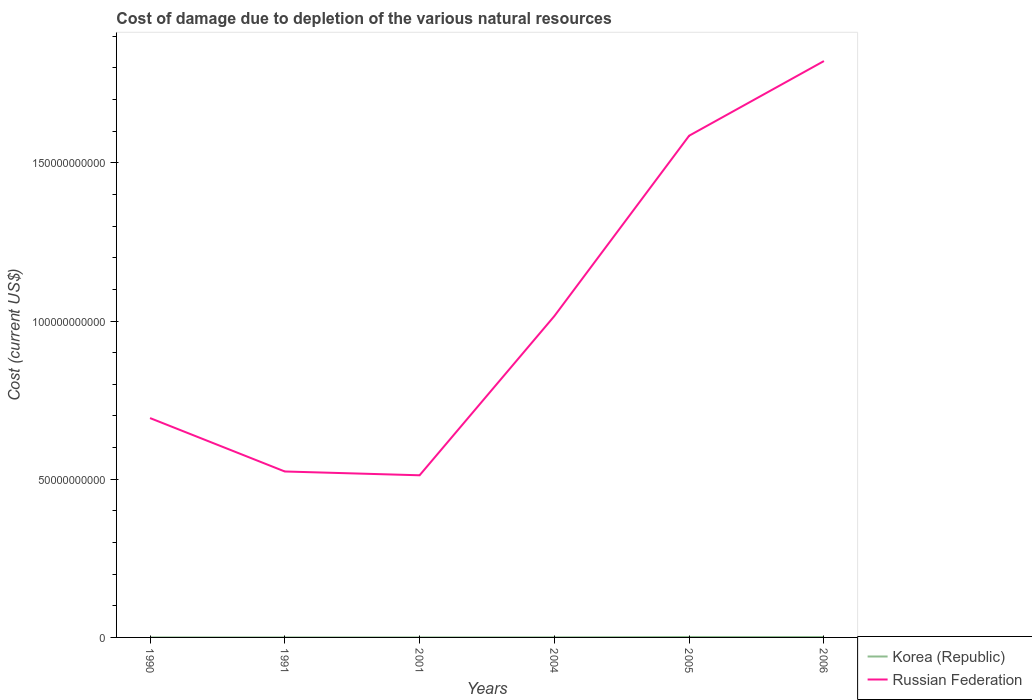How many different coloured lines are there?
Give a very brief answer. 2. Does the line corresponding to Korea (Republic) intersect with the line corresponding to Russian Federation?
Provide a short and direct response. No. Is the number of lines equal to the number of legend labels?
Offer a terse response. Yes. Across all years, what is the maximum cost of damage caused due to the depletion of various natural resources in Korea (Republic)?
Provide a short and direct response. 4.99e+06. In which year was the cost of damage caused due to the depletion of various natural resources in Korea (Republic) maximum?
Provide a short and direct response. 1991. What is the total cost of damage caused due to the depletion of various natural resources in Russian Federation in the graph?
Keep it short and to the point. -1.07e+11. What is the difference between the highest and the second highest cost of damage caused due to the depletion of various natural resources in Russian Federation?
Make the answer very short. 1.31e+11. What is the difference between the highest and the lowest cost of damage caused due to the depletion of various natural resources in Korea (Republic)?
Your answer should be very brief. 2. Is the cost of damage caused due to the depletion of various natural resources in Russian Federation strictly greater than the cost of damage caused due to the depletion of various natural resources in Korea (Republic) over the years?
Give a very brief answer. No. How many years are there in the graph?
Give a very brief answer. 6. What is the difference between two consecutive major ticks on the Y-axis?
Offer a terse response. 5.00e+1. Where does the legend appear in the graph?
Your answer should be very brief. Bottom right. How are the legend labels stacked?
Provide a short and direct response. Vertical. What is the title of the graph?
Offer a terse response. Cost of damage due to depletion of the various natural resources. Does "Guyana" appear as one of the legend labels in the graph?
Your response must be concise. No. What is the label or title of the X-axis?
Keep it short and to the point. Years. What is the label or title of the Y-axis?
Your answer should be compact. Cost (current US$). What is the Cost (current US$) in Korea (Republic) in 1990?
Your answer should be compact. 8.52e+06. What is the Cost (current US$) in Russian Federation in 1990?
Give a very brief answer. 6.93e+1. What is the Cost (current US$) in Korea (Republic) in 1991?
Provide a short and direct response. 4.99e+06. What is the Cost (current US$) of Russian Federation in 1991?
Provide a succinct answer. 5.24e+1. What is the Cost (current US$) in Korea (Republic) in 2001?
Ensure brevity in your answer.  6.16e+06. What is the Cost (current US$) of Russian Federation in 2001?
Offer a terse response. 5.12e+1. What is the Cost (current US$) of Korea (Republic) in 2004?
Your response must be concise. 3.01e+07. What is the Cost (current US$) of Russian Federation in 2004?
Make the answer very short. 1.02e+11. What is the Cost (current US$) in Korea (Republic) in 2005?
Provide a short and direct response. 1.42e+08. What is the Cost (current US$) in Russian Federation in 2005?
Provide a short and direct response. 1.59e+11. What is the Cost (current US$) of Korea (Republic) in 2006?
Offer a terse response. 1.27e+08. What is the Cost (current US$) of Russian Federation in 2006?
Offer a terse response. 1.82e+11. Across all years, what is the maximum Cost (current US$) in Korea (Republic)?
Provide a succinct answer. 1.42e+08. Across all years, what is the maximum Cost (current US$) in Russian Federation?
Your answer should be compact. 1.82e+11. Across all years, what is the minimum Cost (current US$) of Korea (Republic)?
Your response must be concise. 4.99e+06. Across all years, what is the minimum Cost (current US$) in Russian Federation?
Give a very brief answer. 5.12e+1. What is the total Cost (current US$) of Korea (Republic) in the graph?
Ensure brevity in your answer.  3.19e+08. What is the total Cost (current US$) in Russian Federation in the graph?
Offer a terse response. 6.15e+11. What is the difference between the Cost (current US$) in Korea (Republic) in 1990 and that in 1991?
Give a very brief answer. 3.53e+06. What is the difference between the Cost (current US$) in Russian Federation in 1990 and that in 1991?
Offer a terse response. 1.69e+1. What is the difference between the Cost (current US$) of Korea (Republic) in 1990 and that in 2001?
Provide a succinct answer. 2.36e+06. What is the difference between the Cost (current US$) in Russian Federation in 1990 and that in 2001?
Your answer should be very brief. 1.81e+1. What is the difference between the Cost (current US$) in Korea (Republic) in 1990 and that in 2004?
Keep it short and to the point. -2.16e+07. What is the difference between the Cost (current US$) of Russian Federation in 1990 and that in 2004?
Your response must be concise. -3.22e+1. What is the difference between the Cost (current US$) of Korea (Republic) in 1990 and that in 2005?
Your answer should be compact. -1.34e+08. What is the difference between the Cost (current US$) in Russian Federation in 1990 and that in 2005?
Offer a terse response. -8.92e+1. What is the difference between the Cost (current US$) in Korea (Republic) in 1990 and that in 2006?
Ensure brevity in your answer.  -1.19e+08. What is the difference between the Cost (current US$) in Russian Federation in 1990 and that in 2006?
Your response must be concise. -1.13e+11. What is the difference between the Cost (current US$) in Korea (Republic) in 1991 and that in 2001?
Give a very brief answer. -1.17e+06. What is the difference between the Cost (current US$) in Russian Federation in 1991 and that in 2001?
Your response must be concise. 1.20e+09. What is the difference between the Cost (current US$) in Korea (Republic) in 1991 and that in 2004?
Your answer should be compact. -2.51e+07. What is the difference between the Cost (current US$) in Russian Federation in 1991 and that in 2004?
Offer a very short reply. -4.91e+1. What is the difference between the Cost (current US$) in Korea (Republic) in 1991 and that in 2005?
Ensure brevity in your answer.  -1.37e+08. What is the difference between the Cost (current US$) in Russian Federation in 1991 and that in 2005?
Your answer should be compact. -1.06e+11. What is the difference between the Cost (current US$) of Korea (Republic) in 1991 and that in 2006?
Provide a short and direct response. -1.22e+08. What is the difference between the Cost (current US$) in Russian Federation in 1991 and that in 2006?
Provide a short and direct response. -1.30e+11. What is the difference between the Cost (current US$) of Korea (Republic) in 2001 and that in 2004?
Give a very brief answer. -2.40e+07. What is the difference between the Cost (current US$) of Russian Federation in 2001 and that in 2004?
Keep it short and to the point. -5.03e+1. What is the difference between the Cost (current US$) of Korea (Republic) in 2001 and that in 2005?
Offer a very short reply. -1.36e+08. What is the difference between the Cost (current US$) of Russian Federation in 2001 and that in 2005?
Your response must be concise. -1.07e+11. What is the difference between the Cost (current US$) of Korea (Republic) in 2001 and that in 2006?
Your answer should be compact. -1.21e+08. What is the difference between the Cost (current US$) of Russian Federation in 2001 and that in 2006?
Offer a terse response. -1.31e+11. What is the difference between the Cost (current US$) in Korea (Republic) in 2004 and that in 2005?
Your answer should be very brief. -1.12e+08. What is the difference between the Cost (current US$) in Russian Federation in 2004 and that in 2005?
Your answer should be very brief. -5.70e+1. What is the difference between the Cost (current US$) in Korea (Republic) in 2004 and that in 2006?
Provide a succinct answer. -9.72e+07. What is the difference between the Cost (current US$) in Russian Federation in 2004 and that in 2006?
Keep it short and to the point. -8.06e+1. What is the difference between the Cost (current US$) of Korea (Republic) in 2005 and that in 2006?
Ensure brevity in your answer.  1.48e+07. What is the difference between the Cost (current US$) in Russian Federation in 2005 and that in 2006?
Your answer should be compact. -2.36e+1. What is the difference between the Cost (current US$) in Korea (Republic) in 1990 and the Cost (current US$) in Russian Federation in 1991?
Your answer should be very brief. -5.24e+1. What is the difference between the Cost (current US$) of Korea (Republic) in 1990 and the Cost (current US$) of Russian Federation in 2001?
Your answer should be very brief. -5.12e+1. What is the difference between the Cost (current US$) in Korea (Republic) in 1990 and the Cost (current US$) in Russian Federation in 2004?
Your answer should be very brief. -1.02e+11. What is the difference between the Cost (current US$) in Korea (Republic) in 1990 and the Cost (current US$) in Russian Federation in 2005?
Ensure brevity in your answer.  -1.59e+11. What is the difference between the Cost (current US$) in Korea (Republic) in 1990 and the Cost (current US$) in Russian Federation in 2006?
Provide a short and direct response. -1.82e+11. What is the difference between the Cost (current US$) of Korea (Republic) in 1991 and the Cost (current US$) of Russian Federation in 2001?
Your response must be concise. -5.12e+1. What is the difference between the Cost (current US$) in Korea (Republic) in 1991 and the Cost (current US$) in Russian Federation in 2004?
Offer a very short reply. -1.02e+11. What is the difference between the Cost (current US$) of Korea (Republic) in 1991 and the Cost (current US$) of Russian Federation in 2005?
Your answer should be very brief. -1.59e+11. What is the difference between the Cost (current US$) of Korea (Republic) in 1991 and the Cost (current US$) of Russian Federation in 2006?
Offer a very short reply. -1.82e+11. What is the difference between the Cost (current US$) in Korea (Republic) in 2001 and the Cost (current US$) in Russian Federation in 2004?
Your answer should be very brief. -1.02e+11. What is the difference between the Cost (current US$) of Korea (Republic) in 2001 and the Cost (current US$) of Russian Federation in 2005?
Keep it short and to the point. -1.59e+11. What is the difference between the Cost (current US$) of Korea (Republic) in 2001 and the Cost (current US$) of Russian Federation in 2006?
Provide a short and direct response. -1.82e+11. What is the difference between the Cost (current US$) in Korea (Republic) in 2004 and the Cost (current US$) in Russian Federation in 2005?
Your answer should be very brief. -1.59e+11. What is the difference between the Cost (current US$) in Korea (Republic) in 2004 and the Cost (current US$) in Russian Federation in 2006?
Your response must be concise. -1.82e+11. What is the difference between the Cost (current US$) in Korea (Republic) in 2005 and the Cost (current US$) in Russian Federation in 2006?
Offer a very short reply. -1.82e+11. What is the average Cost (current US$) of Korea (Republic) per year?
Keep it short and to the point. 5.32e+07. What is the average Cost (current US$) in Russian Federation per year?
Your answer should be compact. 1.03e+11. In the year 1990, what is the difference between the Cost (current US$) of Korea (Republic) and Cost (current US$) of Russian Federation?
Offer a terse response. -6.93e+1. In the year 1991, what is the difference between the Cost (current US$) of Korea (Republic) and Cost (current US$) of Russian Federation?
Ensure brevity in your answer.  -5.24e+1. In the year 2001, what is the difference between the Cost (current US$) of Korea (Republic) and Cost (current US$) of Russian Federation?
Provide a succinct answer. -5.12e+1. In the year 2004, what is the difference between the Cost (current US$) of Korea (Republic) and Cost (current US$) of Russian Federation?
Give a very brief answer. -1.02e+11. In the year 2005, what is the difference between the Cost (current US$) in Korea (Republic) and Cost (current US$) in Russian Federation?
Keep it short and to the point. -1.58e+11. In the year 2006, what is the difference between the Cost (current US$) in Korea (Republic) and Cost (current US$) in Russian Federation?
Offer a very short reply. -1.82e+11. What is the ratio of the Cost (current US$) in Korea (Republic) in 1990 to that in 1991?
Offer a very short reply. 1.71. What is the ratio of the Cost (current US$) of Russian Federation in 1990 to that in 1991?
Keep it short and to the point. 1.32. What is the ratio of the Cost (current US$) of Korea (Republic) in 1990 to that in 2001?
Keep it short and to the point. 1.38. What is the ratio of the Cost (current US$) of Russian Federation in 1990 to that in 2001?
Your answer should be very brief. 1.35. What is the ratio of the Cost (current US$) of Korea (Republic) in 1990 to that in 2004?
Your response must be concise. 0.28. What is the ratio of the Cost (current US$) of Russian Federation in 1990 to that in 2004?
Keep it short and to the point. 0.68. What is the ratio of the Cost (current US$) in Korea (Republic) in 1990 to that in 2005?
Your answer should be very brief. 0.06. What is the ratio of the Cost (current US$) of Russian Federation in 1990 to that in 2005?
Offer a very short reply. 0.44. What is the ratio of the Cost (current US$) of Korea (Republic) in 1990 to that in 2006?
Offer a very short reply. 0.07. What is the ratio of the Cost (current US$) of Russian Federation in 1990 to that in 2006?
Your answer should be very brief. 0.38. What is the ratio of the Cost (current US$) in Korea (Republic) in 1991 to that in 2001?
Your answer should be very brief. 0.81. What is the ratio of the Cost (current US$) in Russian Federation in 1991 to that in 2001?
Make the answer very short. 1.02. What is the ratio of the Cost (current US$) of Korea (Republic) in 1991 to that in 2004?
Ensure brevity in your answer.  0.17. What is the ratio of the Cost (current US$) of Russian Federation in 1991 to that in 2004?
Keep it short and to the point. 0.52. What is the ratio of the Cost (current US$) of Korea (Republic) in 1991 to that in 2005?
Keep it short and to the point. 0.04. What is the ratio of the Cost (current US$) of Russian Federation in 1991 to that in 2005?
Ensure brevity in your answer.  0.33. What is the ratio of the Cost (current US$) of Korea (Republic) in 1991 to that in 2006?
Offer a terse response. 0.04. What is the ratio of the Cost (current US$) of Russian Federation in 1991 to that in 2006?
Offer a very short reply. 0.29. What is the ratio of the Cost (current US$) of Korea (Republic) in 2001 to that in 2004?
Your answer should be compact. 0.2. What is the ratio of the Cost (current US$) in Russian Federation in 2001 to that in 2004?
Offer a very short reply. 0.5. What is the ratio of the Cost (current US$) of Korea (Republic) in 2001 to that in 2005?
Your response must be concise. 0.04. What is the ratio of the Cost (current US$) of Russian Federation in 2001 to that in 2005?
Ensure brevity in your answer.  0.32. What is the ratio of the Cost (current US$) in Korea (Republic) in 2001 to that in 2006?
Keep it short and to the point. 0.05. What is the ratio of the Cost (current US$) of Russian Federation in 2001 to that in 2006?
Keep it short and to the point. 0.28. What is the ratio of the Cost (current US$) of Korea (Republic) in 2004 to that in 2005?
Your answer should be compact. 0.21. What is the ratio of the Cost (current US$) of Russian Federation in 2004 to that in 2005?
Ensure brevity in your answer.  0.64. What is the ratio of the Cost (current US$) of Korea (Republic) in 2004 to that in 2006?
Give a very brief answer. 0.24. What is the ratio of the Cost (current US$) of Russian Federation in 2004 to that in 2006?
Give a very brief answer. 0.56. What is the ratio of the Cost (current US$) of Korea (Republic) in 2005 to that in 2006?
Your answer should be very brief. 1.12. What is the ratio of the Cost (current US$) of Russian Federation in 2005 to that in 2006?
Your response must be concise. 0.87. What is the difference between the highest and the second highest Cost (current US$) in Korea (Republic)?
Your answer should be compact. 1.48e+07. What is the difference between the highest and the second highest Cost (current US$) in Russian Federation?
Your answer should be very brief. 2.36e+1. What is the difference between the highest and the lowest Cost (current US$) in Korea (Republic)?
Your answer should be compact. 1.37e+08. What is the difference between the highest and the lowest Cost (current US$) in Russian Federation?
Your response must be concise. 1.31e+11. 